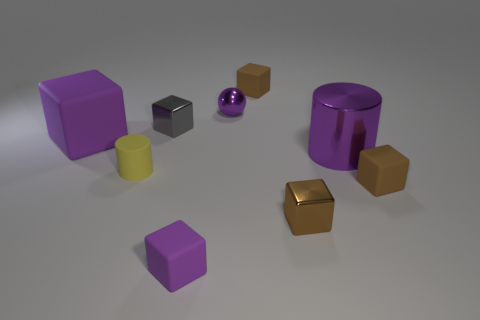Subtract all big matte blocks. How many blocks are left? 5 Subtract all yellow cylinders. How many cylinders are left? 1 Subtract all blocks. How many objects are left? 3 Subtract 2 cylinders. How many cylinders are left? 0 Subtract 2 brown blocks. How many objects are left? 7 Subtract all yellow balls. Subtract all red cylinders. How many balls are left? 1 Subtract all green balls. How many brown blocks are left? 3 Subtract all brown blocks. Subtract all matte cylinders. How many objects are left? 5 Add 6 shiny cubes. How many shiny cubes are left? 8 Add 3 tiny cylinders. How many tiny cylinders exist? 4 